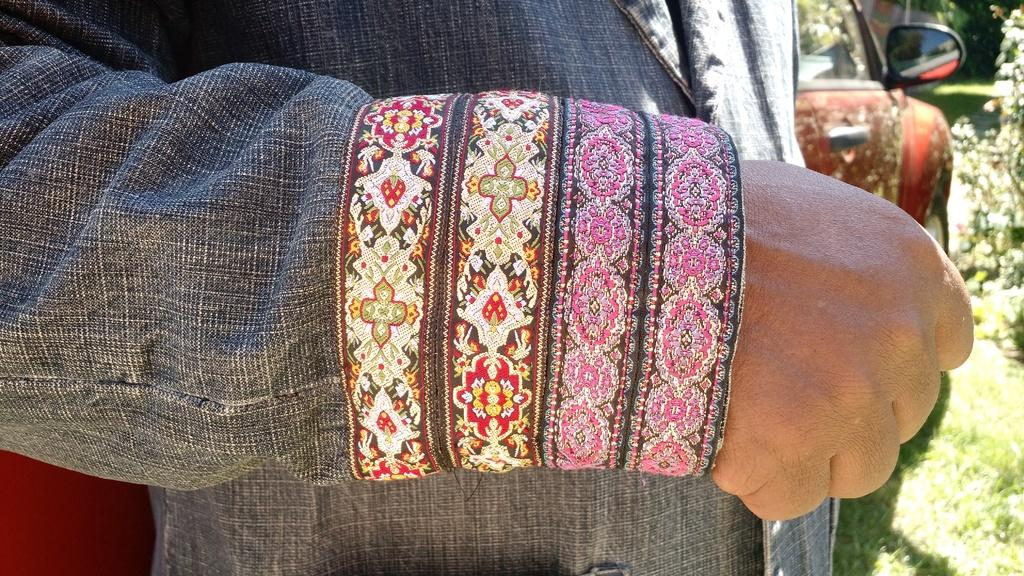Who or what is in the front of the image? There is a person in the front of the image. What type of vegetation is visible at the bottom right corner of the image? There is grass at the right bottom of the image. What mode of transportation can be seen in the image? There is a car in the image. What type of plant is present on the right side of the image? There is a plant on the right side of the image. How many mittens are visible in the image? There are no mittens present in the image. Is there a veil covering the plant on the right side of the image? There is no veil present in the image, and the plant is not covered. 